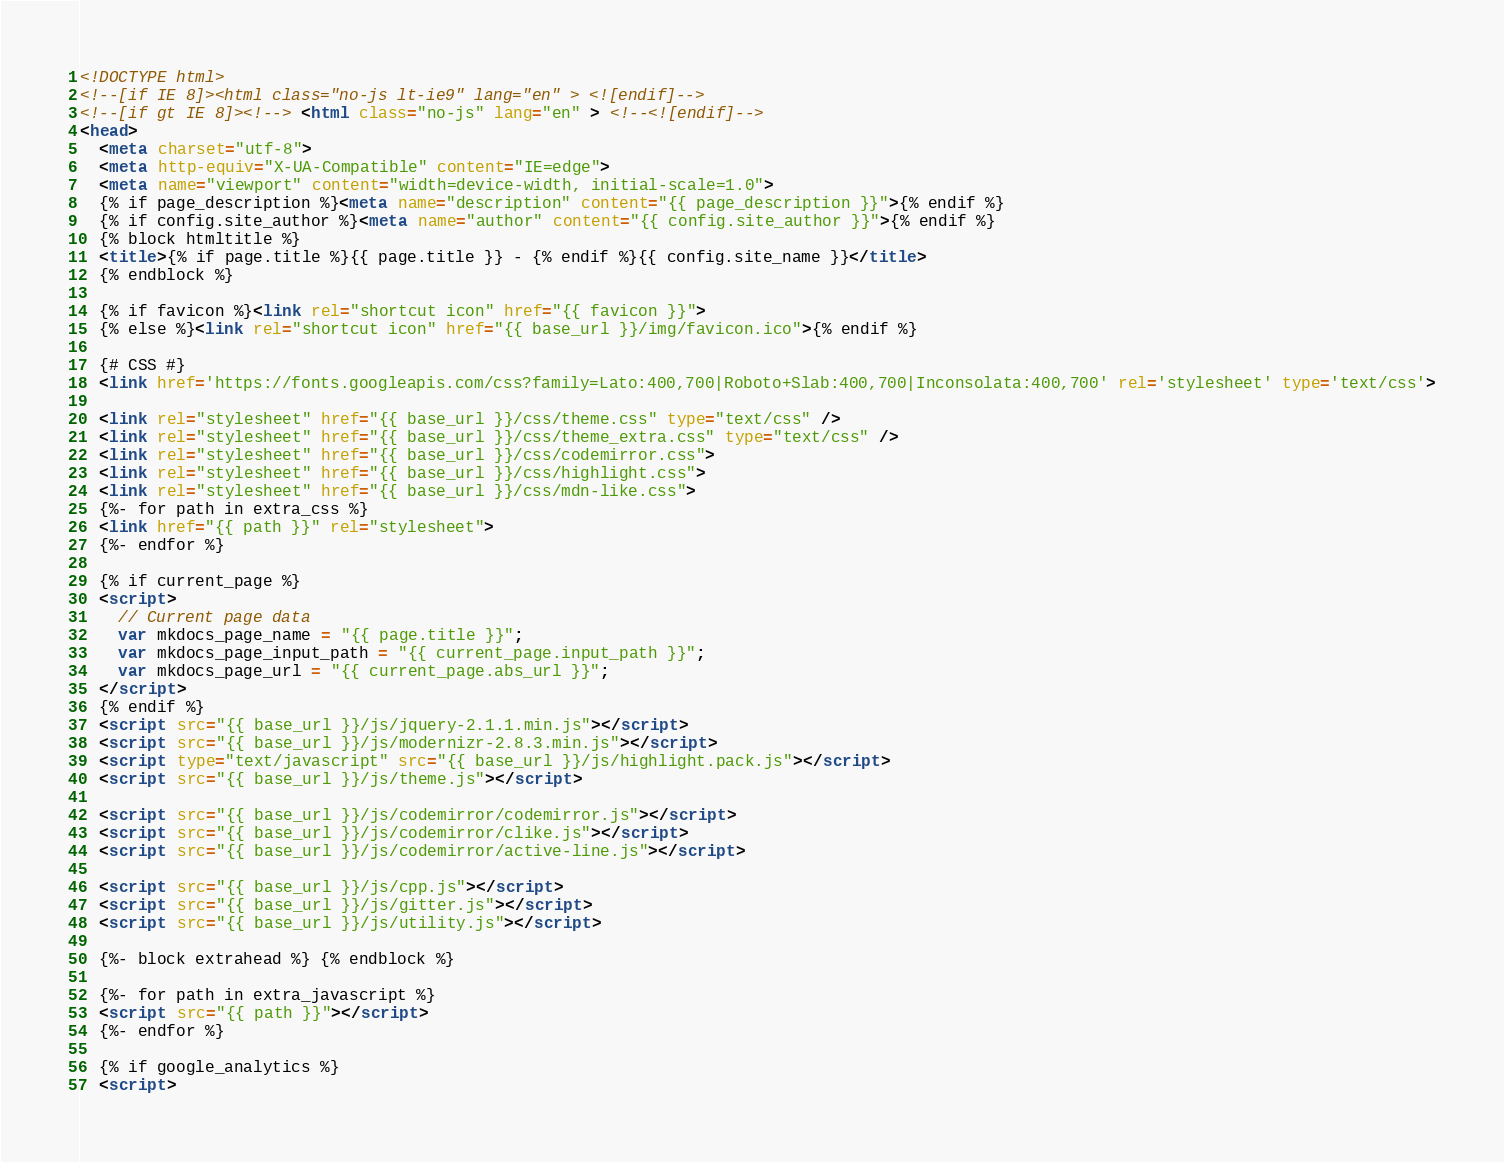Convert code to text. <code><loc_0><loc_0><loc_500><loc_500><_HTML_><!DOCTYPE html>
<!--[if IE 8]><html class="no-js lt-ie9" lang="en" > <![endif]-->
<!--[if gt IE 8]><!--> <html class="no-js" lang="en" > <!--<![endif]-->
<head>
  <meta charset="utf-8">
  <meta http-equiv="X-UA-Compatible" content="IE=edge">
  <meta name="viewport" content="width=device-width, initial-scale=1.0">
  {% if page_description %}<meta name="description" content="{{ page_description }}">{% endif %}
  {% if config.site_author %}<meta name="author" content="{{ config.site_author }}">{% endif %}
  {% block htmltitle %}
  <title>{% if page.title %}{{ page.title }} - {% endif %}{{ config.site_name }}</title>
  {% endblock %}

  {% if favicon %}<link rel="shortcut icon" href="{{ favicon }}">
  {% else %}<link rel="shortcut icon" href="{{ base_url }}/img/favicon.ico">{% endif %}

  {# CSS #}
  <link href='https://fonts.googleapis.com/css?family=Lato:400,700|Roboto+Slab:400,700|Inconsolata:400,700' rel='stylesheet' type='text/css'>

  <link rel="stylesheet" href="{{ base_url }}/css/theme.css" type="text/css" />
  <link rel="stylesheet" href="{{ base_url }}/css/theme_extra.css" type="text/css" />
  <link rel="stylesheet" href="{{ base_url }}/css/codemirror.css">
  <link rel="stylesheet" href="{{ base_url }}/css/highlight.css">
  <link rel="stylesheet" href="{{ base_url }}/css/mdn-like.css">
  {%- for path in extra_css %}
  <link href="{{ path }}" rel="stylesheet">
  {%- endfor %}

  {% if current_page %}
  <script>
    // Current page data
    var mkdocs_page_name = "{{ page.title }}";
    var mkdocs_page_input_path = "{{ current_page.input_path }}";
    var mkdocs_page_url = "{{ current_page.abs_url }}";
  </script>
  {% endif %}
  <script src="{{ base_url }}/js/jquery-2.1.1.min.js"></script>
  <script src="{{ base_url }}/js/modernizr-2.8.3.min.js"></script>
  <script type="text/javascript" src="{{ base_url }}/js/highlight.pack.js"></script>
  <script src="{{ base_url }}/js/theme.js"></script>

  <script src="{{ base_url }}/js/codemirror/codemirror.js"></script>
  <script src="{{ base_url }}/js/codemirror/clike.js"></script>
  <script src="{{ base_url }}/js/codemirror/active-line.js"></script>

  <script src="{{ base_url }}/js/cpp.js"></script>
  <script src="{{ base_url }}/js/gitter.js"></script>
  <script src="{{ base_url }}/js/utility.js"></script>

  {%- block extrahead %} {% endblock %}

  {%- for path in extra_javascript %}
  <script src="{{ path }}"></script>
  {%- endfor %}

  {% if google_analytics %}
  <script></code> 